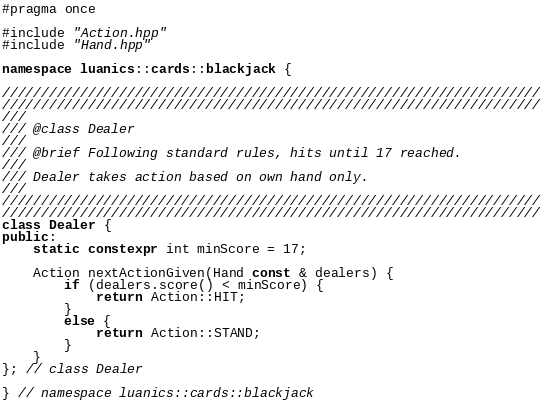Convert code to text. <code><loc_0><loc_0><loc_500><loc_500><_C++_>#pragma once

#include "Action.hpp"
#include "Hand.hpp"

namespace luanics::cards::blackjack {

/////////////////////////////////////////////////////////////////////
/////////////////////////////////////////////////////////////////////
///
/// @class Dealer
///
/// @brief Following standard rules, hits until 17 reached.
///
/// Dealer takes action based on own hand only.
///
/////////////////////////////////////////////////////////////////////
/////////////////////////////////////////////////////////////////////
class Dealer {
public:
	static constexpr int minScore = 17;

	Action nextActionGiven(Hand const & dealers) {
		if (dealers.score() < minScore) {
			return Action::HIT;
		}
		else {
			return Action::STAND;
		}
	}
}; // class Dealer

} // namespace luanics::cards::blackjack
</code> 